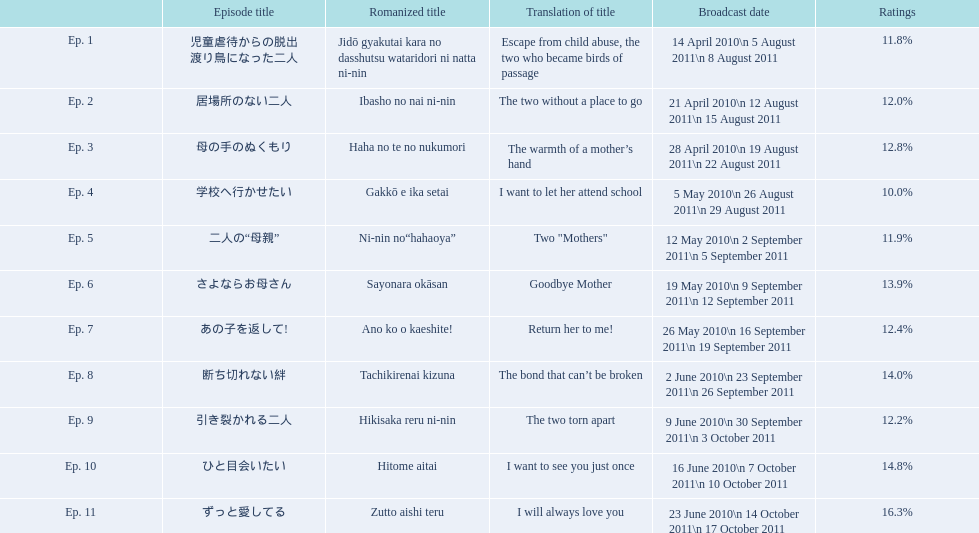What are the entire episode numbers and their titles? Ep. 1, Ep. 2, Ep. 3, Ep. 4, Ep. 5, Ep. 6, Ep. 7, Ep. 8, Ep. 9, Ep. 10, Ep. 11. What about their translated names? 児童虐待からの脱出 渡り鳥になった二人, 居場所のない二人, 母の手のぬくもり, 学校へ行かせたい, 二人の“母親”, さよならお母さん, あの子を返して!, 断ち切れない絆, 引き裂かれる二人, ひと目会いたい, ずっと愛してる. Which episode number's title translated to "i want to let her attend school? Escape from child abuse, the two who became birds of passage, The two without a place to go, The warmth of a mother’s hand, I want to let her attend school, Two "Mothers", Goodbye Mother, Return her to me!, The bond that can’t be broken, The two torn apart, I want to see you just once, I will always love you. "? Ep. 4. 